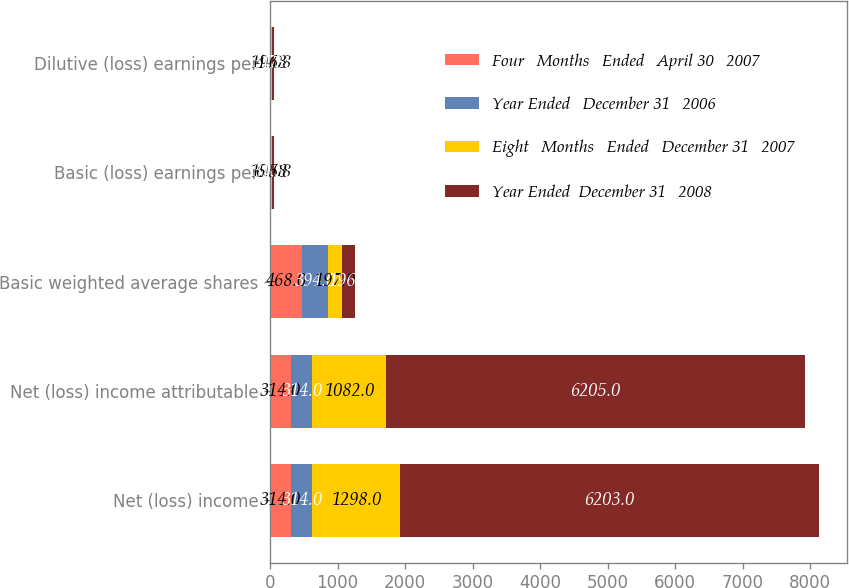Convert chart. <chart><loc_0><loc_0><loc_500><loc_500><stacked_bar_chart><ecel><fcel>Net (loss) income<fcel>Net (loss) income attributable<fcel>Basic weighted average shares<fcel>Basic (loss) earnings per<fcel>Dilutive (loss) earnings per<nl><fcel>Four   Months   Ended   April 30   2007<fcel>314<fcel>314<fcel>468<fcel>19.08<fcel>19.08<nl><fcel>Year Ended   December 31   2006<fcel>314<fcel>314<fcel>394<fcel>0.8<fcel>0.79<nl><fcel>Eight   Months   Ended   December 31   2007<fcel>1298<fcel>1082<fcel>197<fcel>6.58<fcel>4.63<nl><fcel>Year Ended  December 31   2008<fcel>6203<fcel>6205<fcel>196<fcel>31.58<fcel>31.58<nl></chart> 